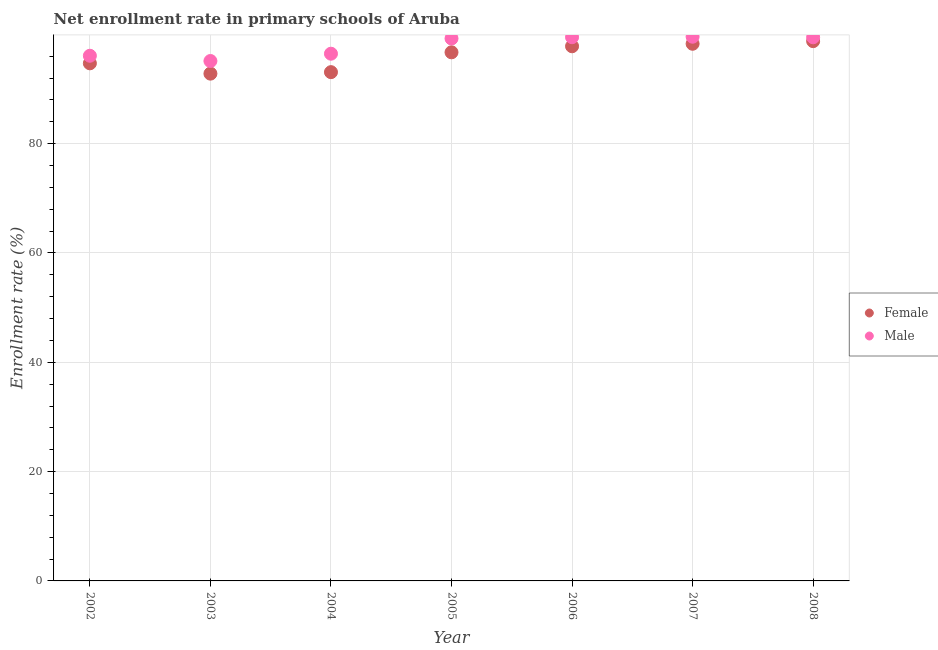Is the number of dotlines equal to the number of legend labels?
Your response must be concise. Yes. What is the enrollment rate of female students in 2004?
Provide a short and direct response. 93.08. Across all years, what is the maximum enrollment rate of female students?
Keep it short and to the point. 98.76. Across all years, what is the minimum enrollment rate of female students?
Offer a terse response. 92.81. In which year was the enrollment rate of female students maximum?
Provide a short and direct response. 2008. What is the total enrollment rate of male students in the graph?
Offer a very short reply. 685.42. What is the difference between the enrollment rate of male students in 2002 and that in 2003?
Your answer should be very brief. 0.96. What is the difference between the enrollment rate of female students in 2006 and the enrollment rate of male students in 2004?
Your answer should be very brief. 1.36. What is the average enrollment rate of female students per year?
Make the answer very short. 96.02. In the year 2006, what is the difference between the enrollment rate of male students and enrollment rate of female students?
Your response must be concise. 1.66. In how many years, is the enrollment rate of female students greater than 4 %?
Keep it short and to the point. 7. What is the ratio of the enrollment rate of male students in 2002 to that in 2007?
Provide a short and direct response. 0.97. Is the enrollment rate of male students in 2004 less than that in 2007?
Your response must be concise. Yes. What is the difference between the highest and the second highest enrollment rate of male students?
Keep it short and to the point. 0.09. What is the difference between the highest and the lowest enrollment rate of female students?
Make the answer very short. 5.94. In how many years, is the enrollment rate of male students greater than the average enrollment rate of male students taken over all years?
Your answer should be compact. 4. Is the sum of the enrollment rate of female students in 2004 and 2005 greater than the maximum enrollment rate of male students across all years?
Make the answer very short. Yes. Does the enrollment rate of male students monotonically increase over the years?
Provide a short and direct response. No. Is the enrollment rate of female students strictly greater than the enrollment rate of male students over the years?
Provide a succinct answer. No. Is the enrollment rate of male students strictly less than the enrollment rate of female students over the years?
Make the answer very short. No. How many years are there in the graph?
Provide a short and direct response. 7. What is the difference between two consecutive major ticks on the Y-axis?
Offer a terse response. 20. Does the graph contain any zero values?
Provide a short and direct response. No. Does the graph contain grids?
Your answer should be very brief. Yes. How are the legend labels stacked?
Ensure brevity in your answer.  Vertical. What is the title of the graph?
Provide a short and direct response. Net enrollment rate in primary schools of Aruba. Does "Lowest 10% of population" appear as one of the legend labels in the graph?
Provide a short and direct response. No. What is the label or title of the Y-axis?
Offer a terse response. Enrollment rate (%). What is the Enrollment rate (%) in Female in 2002?
Provide a short and direct response. 94.7. What is the Enrollment rate (%) in Male in 2002?
Make the answer very short. 96.08. What is the Enrollment rate (%) of Female in 2003?
Ensure brevity in your answer.  92.81. What is the Enrollment rate (%) of Male in 2003?
Ensure brevity in your answer.  95.13. What is the Enrollment rate (%) in Female in 2004?
Give a very brief answer. 93.08. What is the Enrollment rate (%) in Male in 2004?
Offer a terse response. 96.46. What is the Enrollment rate (%) of Female in 2005?
Offer a terse response. 96.72. What is the Enrollment rate (%) of Male in 2005?
Provide a succinct answer. 99.24. What is the Enrollment rate (%) of Female in 2006?
Make the answer very short. 97.82. What is the Enrollment rate (%) of Male in 2006?
Your answer should be very brief. 99.48. What is the Enrollment rate (%) of Female in 2007?
Your response must be concise. 98.28. What is the Enrollment rate (%) of Male in 2007?
Offer a terse response. 99.57. What is the Enrollment rate (%) in Female in 2008?
Offer a very short reply. 98.76. What is the Enrollment rate (%) of Male in 2008?
Your answer should be very brief. 99.46. Across all years, what is the maximum Enrollment rate (%) of Female?
Offer a very short reply. 98.76. Across all years, what is the maximum Enrollment rate (%) in Male?
Provide a succinct answer. 99.57. Across all years, what is the minimum Enrollment rate (%) in Female?
Ensure brevity in your answer.  92.81. Across all years, what is the minimum Enrollment rate (%) of Male?
Ensure brevity in your answer.  95.13. What is the total Enrollment rate (%) of Female in the graph?
Ensure brevity in your answer.  672.17. What is the total Enrollment rate (%) of Male in the graph?
Your answer should be compact. 685.42. What is the difference between the Enrollment rate (%) of Female in 2002 and that in 2003?
Keep it short and to the point. 1.89. What is the difference between the Enrollment rate (%) in Male in 2002 and that in 2003?
Provide a succinct answer. 0.96. What is the difference between the Enrollment rate (%) of Female in 2002 and that in 2004?
Provide a succinct answer. 1.62. What is the difference between the Enrollment rate (%) of Male in 2002 and that in 2004?
Your answer should be very brief. -0.38. What is the difference between the Enrollment rate (%) of Female in 2002 and that in 2005?
Keep it short and to the point. -2.02. What is the difference between the Enrollment rate (%) in Male in 2002 and that in 2005?
Provide a succinct answer. -3.16. What is the difference between the Enrollment rate (%) in Female in 2002 and that in 2006?
Provide a succinct answer. -3.12. What is the difference between the Enrollment rate (%) of Male in 2002 and that in 2006?
Your answer should be compact. -3.39. What is the difference between the Enrollment rate (%) in Female in 2002 and that in 2007?
Your answer should be very brief. -3.58. What is the difference between the Enrollment rate (%) in Male in 2002 and that in 2007?
Keep it short and to the point. -3.48. What is the difference between the Enrollment rate (%) of Female in 2002 and that in 2008?
Your answer should be compact. -4.06. What is the difference between the Enrollment rate (%) of Male in 2002 and that in 2008?
Provide a succinct answer. -3.38. What is the difference between the Enrollment rate (%) of Female in 2003 and that in 2004?
Provide a succinct answer. -0.27. What is the difference between the Enrollment rate (%) of Male in 2003 and that in 2004?
Your response must be concise. -1.34. What is the difference between the Enrollment rate (%) of Female in 2003 and that in 2005?
Keep it short and to the point. -3.9. What is the difference between the Enrollment rate (%) of Male in 2003 and that in 2005?
Offer a terse response. -4.12. What is the difference between the Enrollment rate (%) in Female in 2003 and that in 2006?
Offer a terse response. -5.01. What is the difference between the Enrollment rate (%) in Male in 2003 and that in 2006?
Offer a very short reply. -4.35. What is the difference between the Enrollment rate (%) of Female in 2003 and that in 2007?
Offer a terse response. -5.47. What is the difference between the Enrollment rate (%) of Male in 2003 and that in 2007?
Offer a terse response. -4.44. What is the difference between the Enrollment rate (%) of Female in 2003 and that in 2008?
Your answer should be very brief. -5.94. What is the difference between the Enrollment rate (%) of Male in 2003 and that in 2008?
Ensure brevity in your answer.  -4.34. What is the difference between the Enrollment rate (%) of Female in 2004 and that in 2005?
Your answer should be very brief. -3.63. What is the difference between the Enrollment rate (%) in Male in 2004 and that in 2005?
Keep it short and to the point. -2.78. What is the difference between the Enrollment rate (%) in Female in 2004 and that in 2006?
Your answer should be compact. -4.74. What is the difference between the Enrollment rate (%) in Male in 2004 and that in 2006?
Offer a terse response. -3.02. What is the difference between the Enrollment rate (%) in Female in 2004 and that in 2007?
Offer a terse response. -5.19. What is the difference between the Enrollment rate (%) in Male in 2004 and that in 2007?
Provide a succinct answer. -3.11. What is the difference between the Enrollment rate (%) in Female in 2004 and that in 2008?
Ensure brevity in your answer.  -5.67. What is the difference between the Enrollment rate (%) of Male in 2004 and that in 2008?
Your answer should be compact. -3. What is the difference between the Enrollment rate (%) of Female in 2005 and that in 2006?
Your response must be concise. -1.1. What is the difference between the Enrollment rate (%) in Male in 2005 and that in 2006?
Offer a terse response. -0.24. What is the difference between the Enrollment rate (%) in Female in 2005 and that in 2007?
Offer a very short reply. -1.56. What is the difference between the Enrollment rate (%) in Male in 2005 and that in 2007?
Offer a very short reply. -0.33. What is the difference between the Enrollment rate (%) in Female in 2005 and that in 2008?
Your response must be concise. -2.04. What is the difference between the Enrollment rate (%) in Male in 2005 and that in 2008?
Offer a terse response. -0.22. What is the difference between the Enrollment rate (%) in Female in 2006 and that in 2007?
Offer a very short reply. -0.46. What is the difference between the Enrollment rate (%) of Male in 2006 and that in 2007?
Make the answer very short. -0.09. What is the difference between the Enrollment rate (%) of Female in 2006 and that in 2008?
Offer a very short reply. -0.94. What is the difference between the Enrollment rate (%) of Male in 2006 and that in 2008?
Your answer should be compact. 0.01. What is the difference between the Enrollment rate (%) in Female in 2007 and that in 2008?
Make the answer very short. -0.48. What is the difference between the Enrollment rate (%) in Male in 2007 and that in 2008?
Ensure brevity in your answer.  0.1. What is the difference between the Enrollment rate (%) of Female in 2002 and the Enrollment rate (%) of Male in 2003?
Give a very brief answer. -0.43. What is the difference between the Enrollment rate (%) of Female in 2002 and the Enrollment rate (%) of Male in 2004?
Provide a short and direct response. -1.76. What is the difference between the Enrollment rate (%) of Female in 2002 and the Enrollment rate (%) of Male in 2005?
Give a very brief answer. -4.54. What is the difference between the Enrollment rate (%) of Female in 2002 and the Enrollment rate (%) of Male in 2006?
Provide a short and direct response. -4.78. What is the difference between the Enrollment rate (%) of Female in 2002 and the Enrollment rate (%) of Male in 2007?
Your response must be concise. -4.87. What is the difference between the Enrollment rate (%) in Female in 2002 and the Enrollment rate (%) in Male in 2008?
Provide a succinct answer. -4.77. What is the difference between the Enrollment rate (%) in Female in 2003 and the Enrollment rate (%) in Male in 2004?
Offer a very short reply. -3.65. What is the difference between the Enrollment rate (%) in Female in 2003 and the Enrollment rate (%) in Male in 2005?
Provide a short and direct response. -6.43. What is the difference between the Enrollment rate (%) of Female in 2003 and the Enrollment rate (%) of Male in 2006?
Provide a succinct answer. -6.66. What is the difference between the Enrollment rate (%) in Female in 2003 and the Enrollment rate (%) in Male in 2007?
Provide a succinct answer. -6.75. What is the difference between the Enrollment rate (%) of Female in 2003 and the Enrollment rate (%) of Male in 2008?
Offer a very short reply. -6.65. What is the difference between the Enrollment rate (%) of Female in 2004 and the Enrollment rate (%) of Male in 2005?
Provide a short and direct response. -6.16. What is the difference between the Enrollment rate (%) of Female in 2004 and the Enrollment rate (%) of Male in 2006?
Provide a short and direct response. -6.39. What is the difference between the Enrollment rate (%) in Female in 2004 and the Enrollment rate (%) in Male in 2007?
Keep it short and to the point. -6.48. What is the difference between the Enrollment rate (%) of Female in 2004 and the Enrollment rate (%) of Male in 2008?
Provide a short and direct response. -6.38. What is the difference between the Enrollment rate (%) in Female in 2005 and the Enrollment rate (%) in Male in 2006?
Your response must be concise. -2.76. What is the difference between the Enrollment rate (%) of Female in 2005 and the Enrollment rate (%) of Male in 2007?
Give a very brief answer. -2.85. What is the difference between the Enrollment rate (%) in Female in 2005 and the Enrollment rate (%) in Male in 2008?
Ensure brevity in your answer.  -2.75. What is the difference between the Enrollment rate (%) of Female in 2006 and the Enrollment rate (%) of Male in 2007?
Make the answer very short. -1.75. What is the difference between the Enrollment rate (%) in Female in 2006 and the Enrollment rate (%) in Male in 2008?
Your answer should be compact. -1.65. What is the difference between the Enrollment rate (%) of Female in 2007 and the Enrollment rate (%) of Male in 2008?
Keep it short and to the point. -1.19. What is the average Enrollment rate (%) of Female per year?
Ensure brevity in your answer.  96.02. What is the average Enrollment rate (%) of Male per year?
Make the answer very short. 97.92. In the year 2002, what is the difference between the Enrollment rate (%) of Female and Enrollment rate (%) of Male?
Keep it short and to the point. -1.38. In the year 2003, what is the difference between the Enrollment rate (%) in Female and Enrollment rate (%) in Male?
Keep it short and to the point. -2.31. In the year 2004, what is the difference between the Enrollment rate (%) of Female and Enrollment rate (%) of Male?
Your answer should be very brief. -3.38. In the year 2005, what is the difference between the Enrollment rate (%) in Female and Enrollment rate (%) in Male?
Provide a short and direct response. -2.52. In the year 2006, what is the difference between the Enrollment rate (%) in Female and Enrollment rate (%) in Male?
Keep it short and to the point. -1.66. In the year 2007, what is the difference between the Enrollment rate (%) in Female and Enrollment rate (%) in Male?
Offer a terse response. -1.29. In the year 2008, what is the difference between the Enrollment rate (%) of Female and Enrollment rate (%) of Male?
Offer a terse response. -0.71. What is the ratio of the Enrollment rate (%) in Female in 2002 to that in 2003?
Make the answer very short. 1.02. What is the ratio of the Enrollment rate (%) in Female in 2002 to that in 2004?
Your answer should be compact. 1.02. What is the ratio of the Enrollment rate (%) of Male in 2002 to that in 2004?
Your answer should be compact. 1. What is the ratio of the Enrollment rate (%) in Female in 2002 to that in 2005?
Give a very brief answer. 0.98. What is the ratio of the Enrollment rate (%) of Male in 2002 to that in 2005?
Keep it short and to the point. 0.97. What is the ratio of the Enrollment rate (%) of Female in 2002 to that in 2006?
Your answer should be very brief. 0.97. What is the ratio of the Enrollment rate (%) in Male in 2002 to that in 2006?
Make the answer very short. 0.97. What is the ratio of the Enrollment rate (%) of Female in 2002 to that in 2007?
Keep it short and to the point. 0.96. What is the ratio of the Enrollment rate (%) in Female in 2002 to that in 2008?
Offer a very short reply. 0.96. What is the ratio of the Enrollment rate (%) of Female in 2003 to that in 2004?
Provide a short and direct response. 1. What is the ratio of the Enrollment rate (%) of Male in 2003 to that in 2004?
Provide a succinct answer. 0.99. What is the ratio of the Enrollment rate (%) of Female in 2003 to that in 2005?
Your answer should be compact. 0.96. What is the ratio of the Enrollment rate (%) of Male in 2003 to that in 2005?
Offer a very short reply. 0.96. What is the ratio of the Enrollment rate (%) in Female in 2003 to that in 2006?
Your answer should be very brief. 0.95. What is the ratio of the Enrollment rate (%) in Male in 2003 to that in 2006?
Make the answer very short. 0.96. What is the ratio of the Enrollment rate (%) of Female in 2003 to that in 2007?
Offer a terse response. 0.94. What is the ratio of the Enrollment rate (%) of Male in 2003 to that in 2007?
Your response must be concise. 0.96. What is the ratio of the Enrollment rate (%) of Female in 2003 to that in 2008?
Your answer should be very brief. 0.94. What is the ratio of the Enrollment rate (%) of Male in 2003 to that in 2008?
Keep it short and to the point. 0.96. What is the ratio of the Enrollment rate (%) in Female in 2004 to that in 2005?
Provide a succinct answer. 0.96. What is the ratio of the Enrollment rate (%) of Female in 2004 to that in 2006?
Your answer should be very brief. 0.95. What is the ratio of the Enrollment rate (%) in Male in 2004 to that in 2006?
Ensure brevity in your answer.  0.97. What is the ratio of the Enrollment rate (%) in Female in 2004 to that in 2007?
Ensure brevity in your answer.  0.95. What is the ratio of the Enrollment rate (%) in Male in 2004 to that in 2007?
Your answer should be very brief. 0.97. What is the ratio of the Enrollment rate (%) in Female in 2004 to that in 2008?
Your answer should be compact. 0.94. What is the ratio of the Enrollment rate (%) in Male in 2004 to that in 2008?
Offer a very short reply. 0.97. What is the ratio of the Enrollment rate (%) in Female in 2005 to that in 2006?
Offer a terse response. 0.99. What is the ratio of the Enrollment rate (%) of Male in 2005 to that in 2006?
Make the answer very short. 1. What is the ratio of the Enrollment rate (%) in Female in 2005 to that in 2007?
Your answer should be very brief. 0.98. What is the ratio of the Enrollment rate (%) in Female in 2005 to that in 2008?
Provide a succinct answer. 0.98. What is the ratio of the Enrollment rate (%) in Female in 2006 to that in 2007?
Provide a succinct answer. 1. What is the ratio of the Enrollment rate (%) in Female in 2006 to that in 2008?
Provide a short and direct response. 0.99. What is the ratio of the Enrollment rate (%) of Female in 2007 to that in 2008?
Your answer should be very brief. 1. What is the difference between the highest and the second highest Enrollment rate (%) in Female?
Your answer should be compact. 0.48. What is the difference between the highest and the second highest Enrollment rate (%) of Male?
Make the answer very short. 0.09. What is the difference between the highest and the lowest Enrollment rate (%) in Female?
Give a very brief answer. 5.94. What is the difference between the highest and the lowest Enrollment rate (%) in Male?
Give a very brief answer. 4.44. 